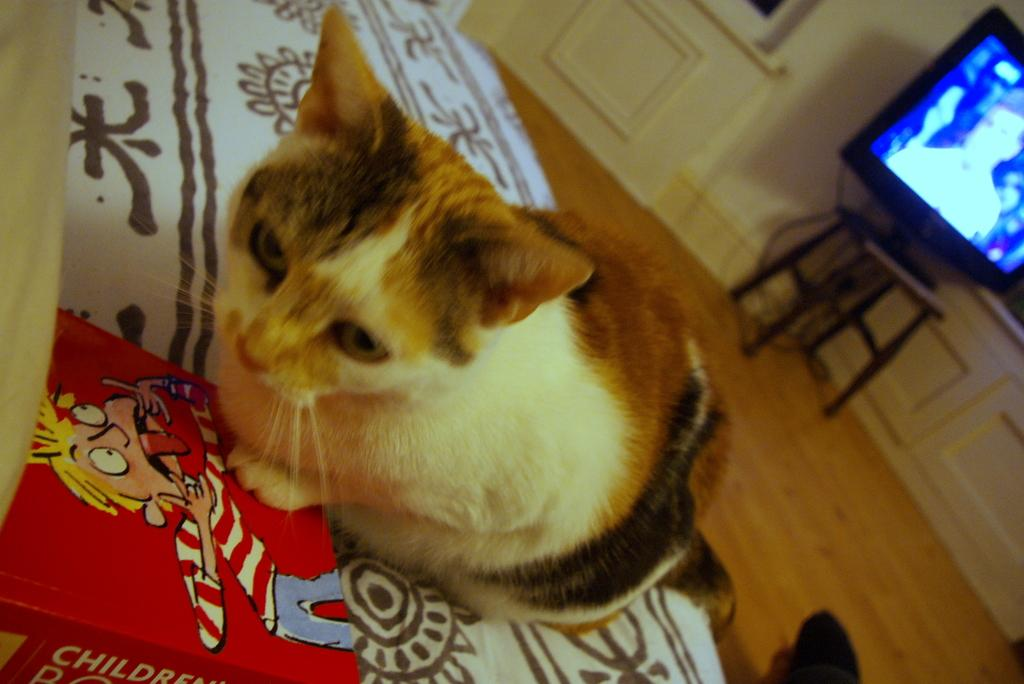What type of animal is on the bed in the image? There is a cat on the bed in the image. Where is the book located in the image? The book is in the bottom left of the image. What is the TV resting on in the image? The TV is on a stool on the right side of the image. What type of salt is sprinkled on the rose in the image? There is no salt or rose present in the image. How many pickles are visible on the cat in the image? There are no pickles present in the image, and the cat is not interacting with any pickles. 